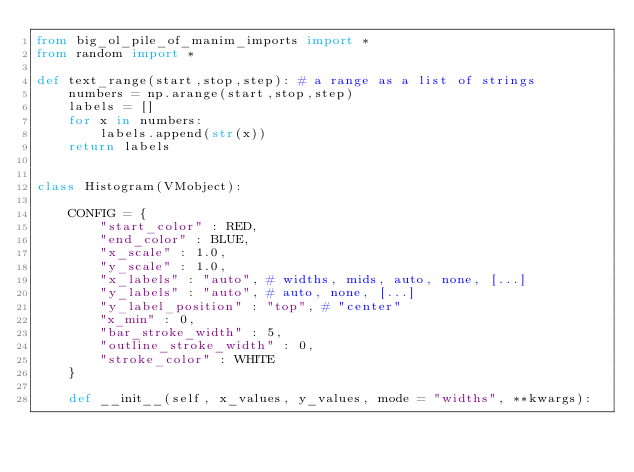<code> <loc_0><loc_0><loc_500><loc_500><_Python_>from big_ol_pile_of_manim_imports import *
from random import *

def text_range(start,stop,step): # a range as a list of strings
    numbers = np.arange(start,stop,step)
    labels = []
    for x in numbers:
        labels.append(str(x))
    return labels


class Histogram(VMobject):

    CONFIG = {
        "start_color" : RED,
        "end_color" : BLUE,
        "x_scale" : 1.0,
        "y_scale" : 1.0,
        "x_labels" : "auto", # widths, mids, auto, none, [...]
        "y_labels" : "auto", # auto, none, [...]
        "y_label_position" : "top", # "center"
        "x_min" : 0,
        "bar_stroke_width" : 5,
        "outline_stroke_width" : 0,
        "stroke_color" : WHITE
    }

    def __init__(self, x_values, y_values, mode = "widths", **kwargs):</code> 